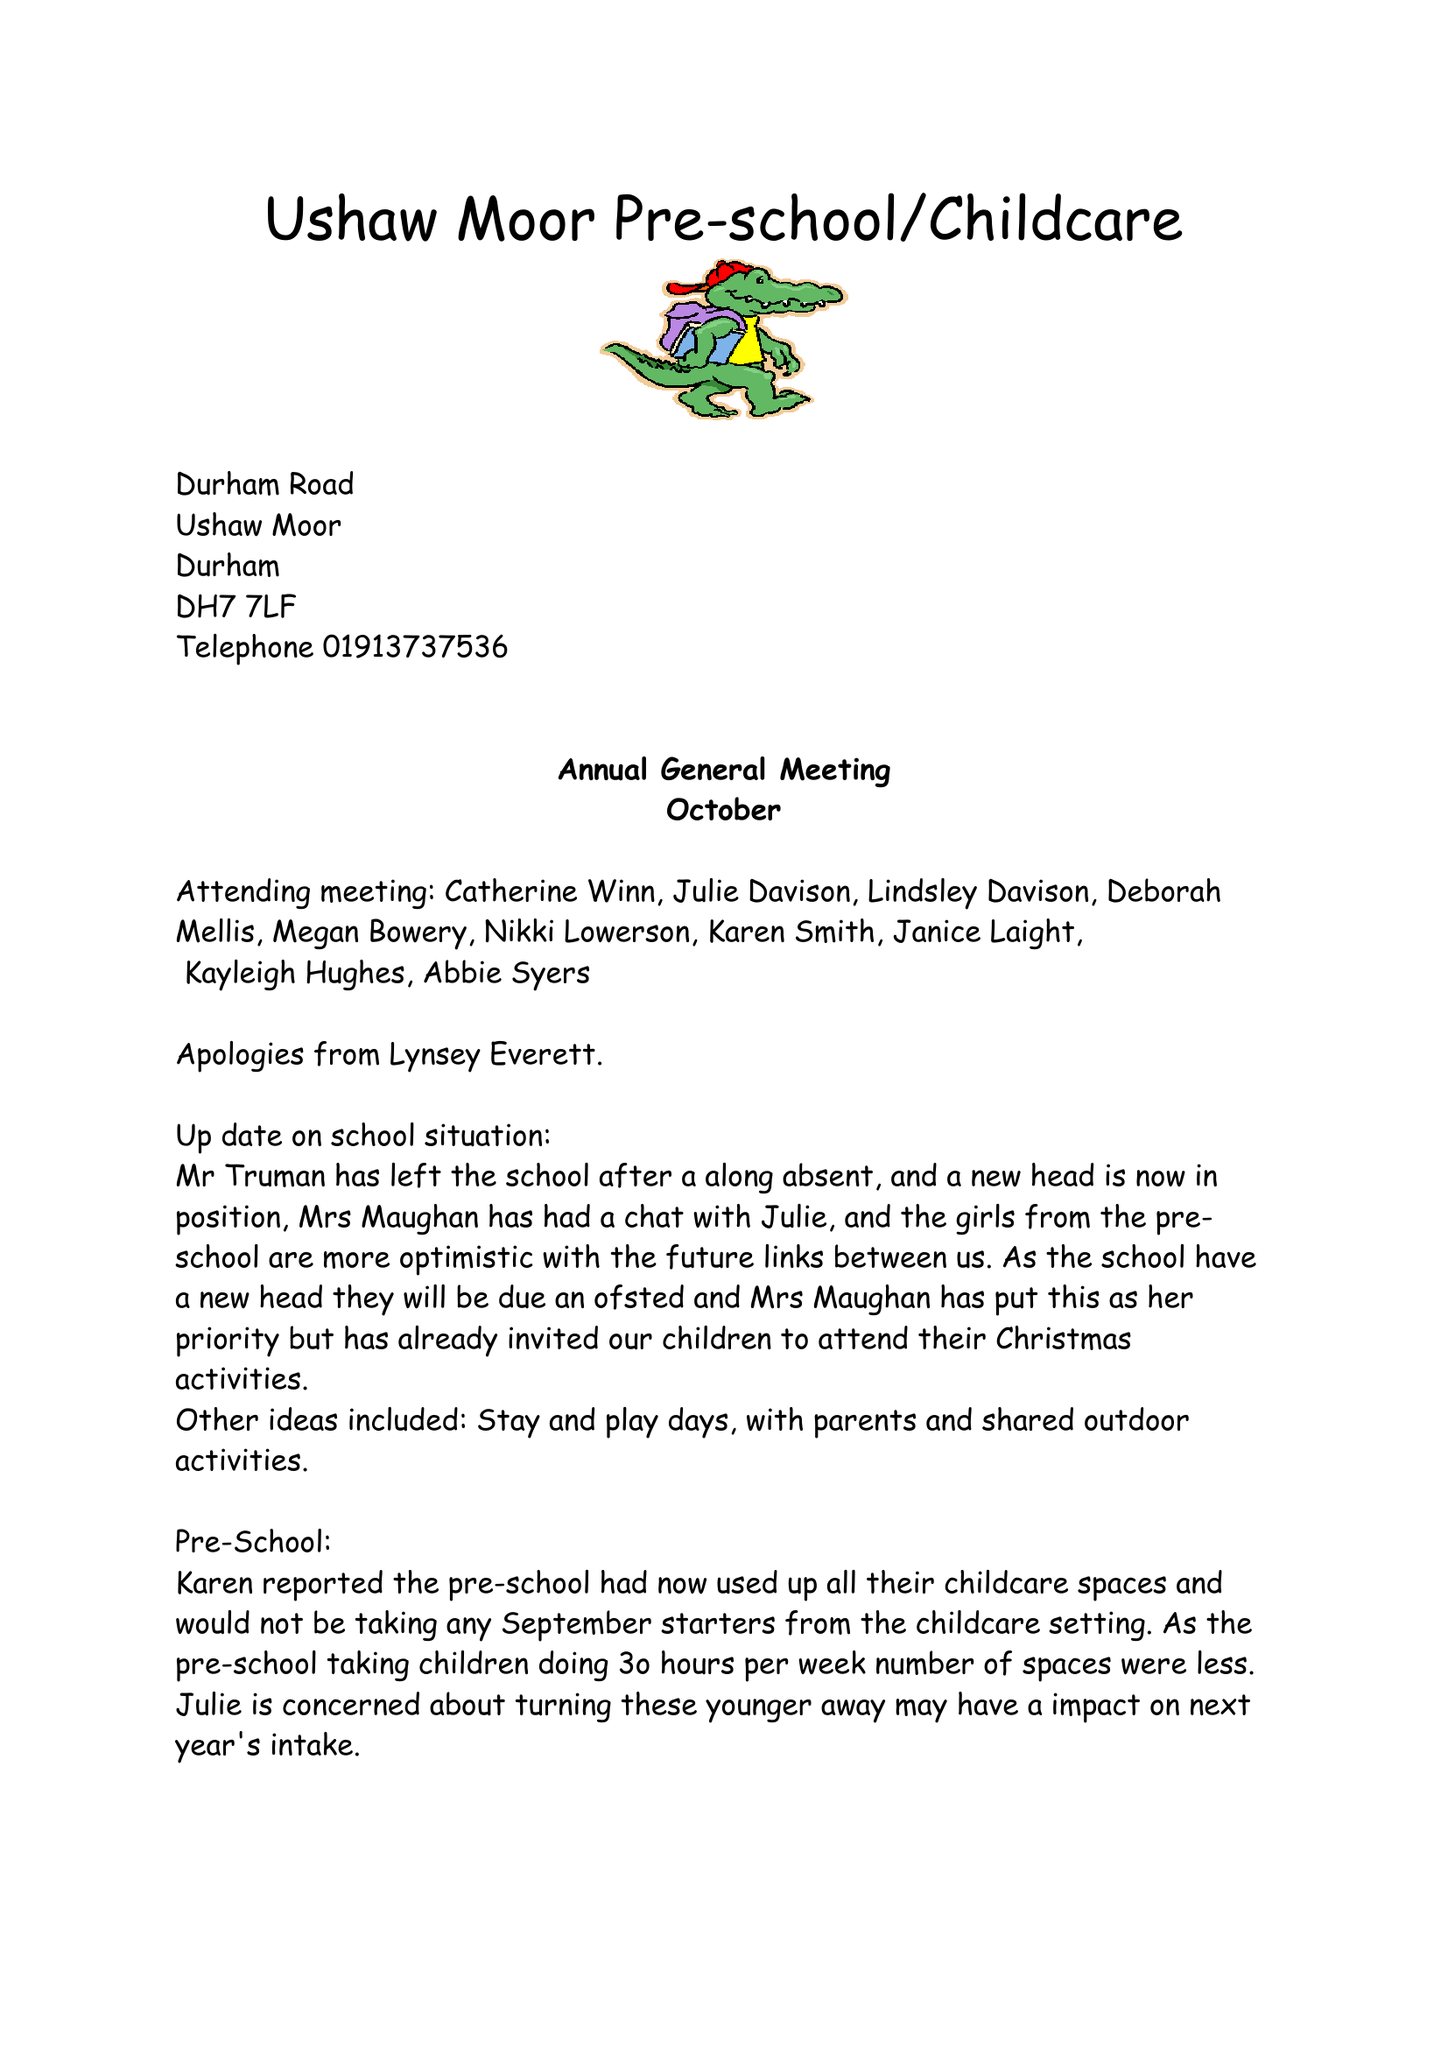What is the value for the report_date?
Answer the question using a single word or phrase. 2017-10-31 